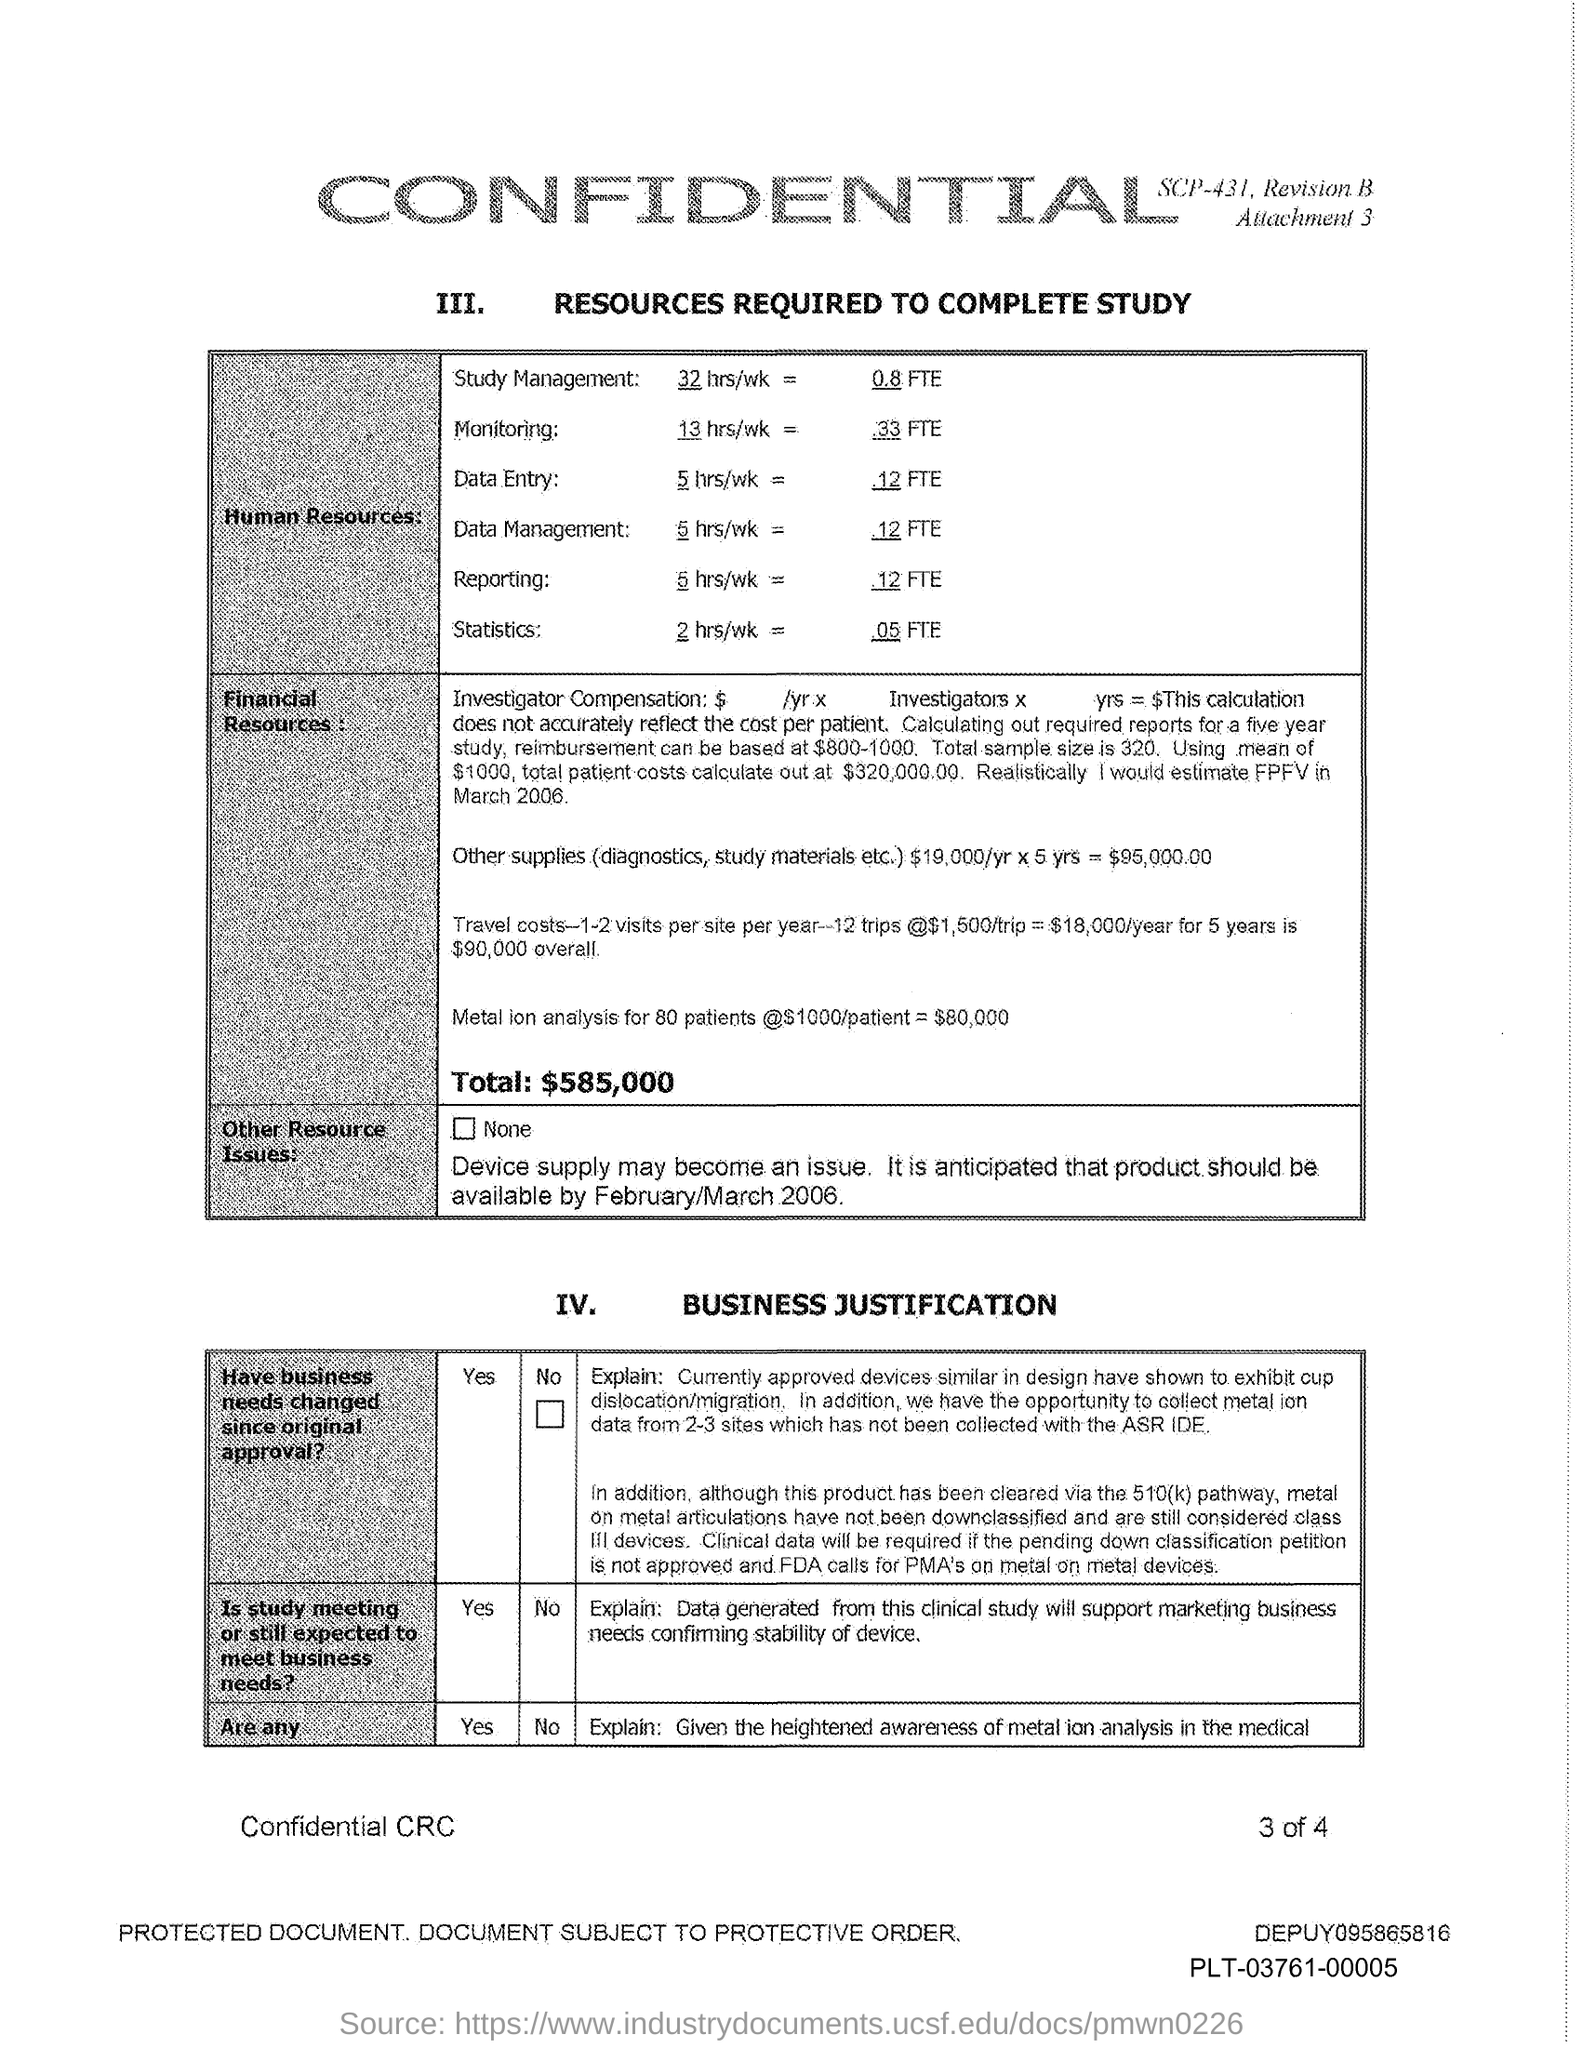Point out several critical features in this image. The heading of a table with the Roman number IV represents the business justification for a particular purpose. It is recommended that the monitoring task be performed for a total of 13 hours per week. 